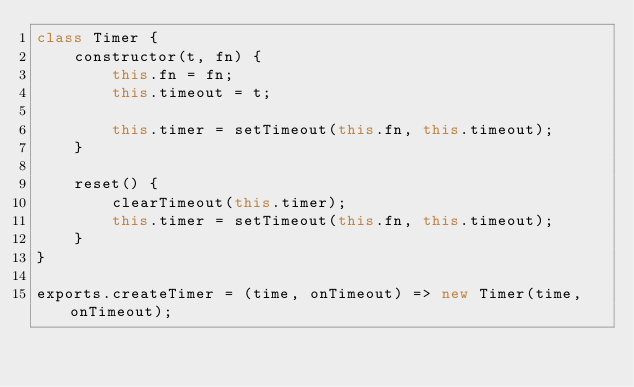Convert code to text. <code><loc_0><loc_0><loc_500><loc_500><_JavaScript_>class Timer {
    constructor(t, fn) {
        this.fn = fn;
        this.timeout = t;

        this.timer = setTimeout(this.fn, this.timeout);
    }

    reset() {
        clearTimeout(this.timer);
        this.timer = setTimeout(this.fn, this.timeout);
    }
}

exports.createTimer = (time, onTimeout) => new Timer(time, onTimeout);</code> 